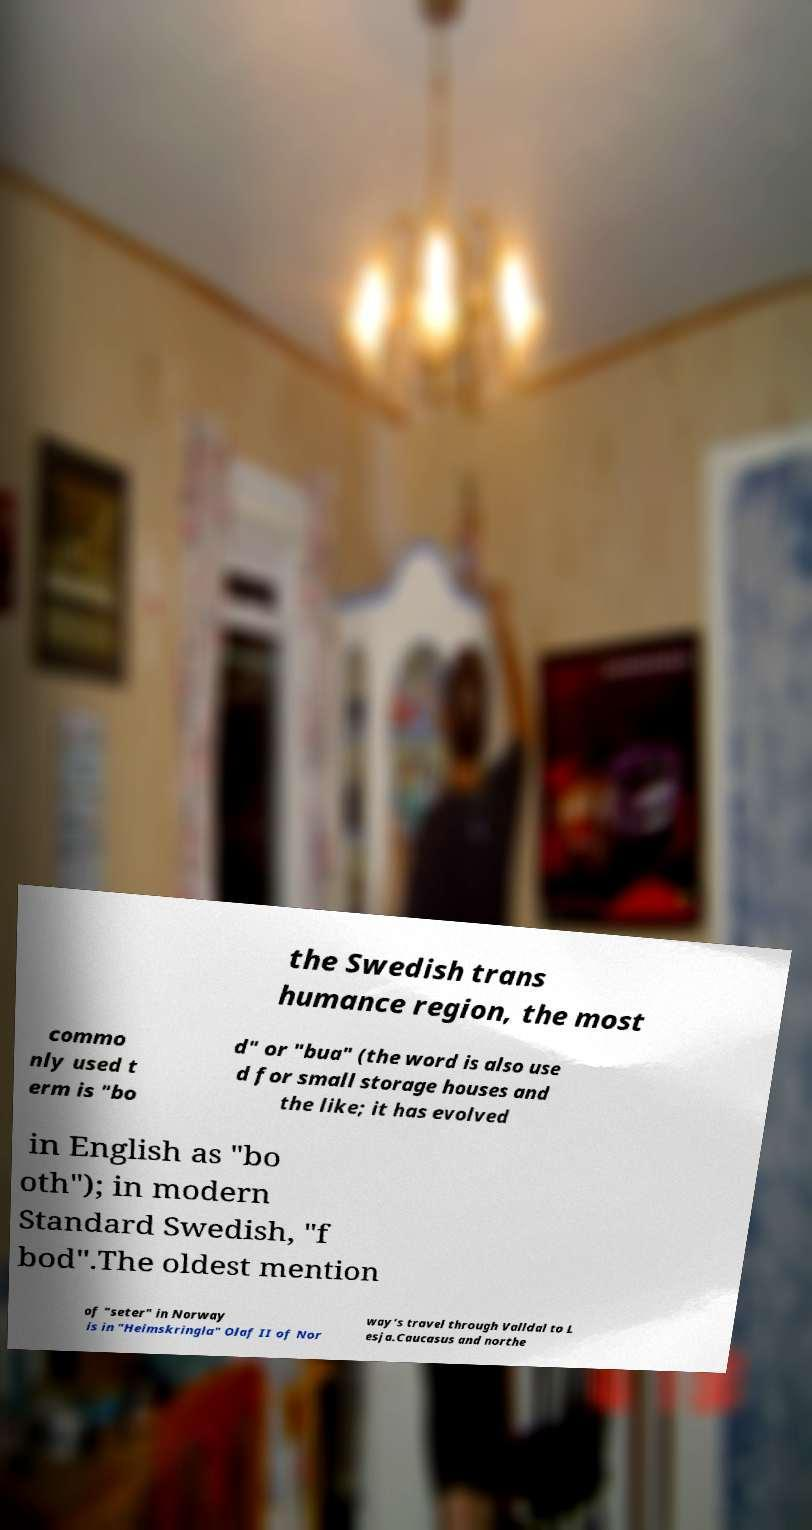Can you accurately transcribe the text from the provided image for me? the Swedish trans humance region, the most commo nly used t erm is "bo d" or "bua" (the word is also use d for small storage houses and the like; it has evolved in English as "bo oth"); in modern Standard Swedish, "f bod".The oldest mention of "seter" in Norway is in "Heimskringla" Olaf II of Nor way's travel through Valldal to L esja.Caucasus and northe 